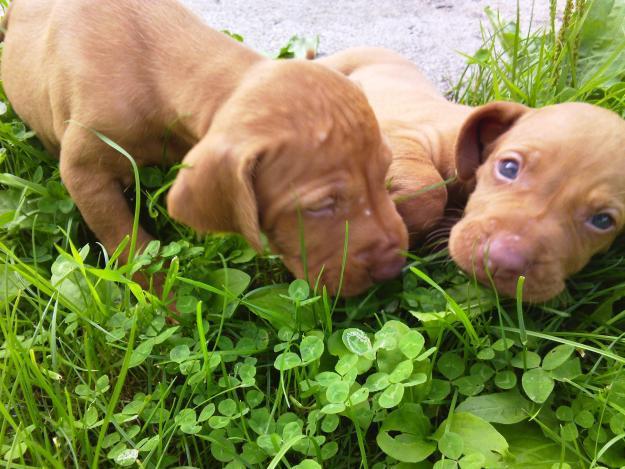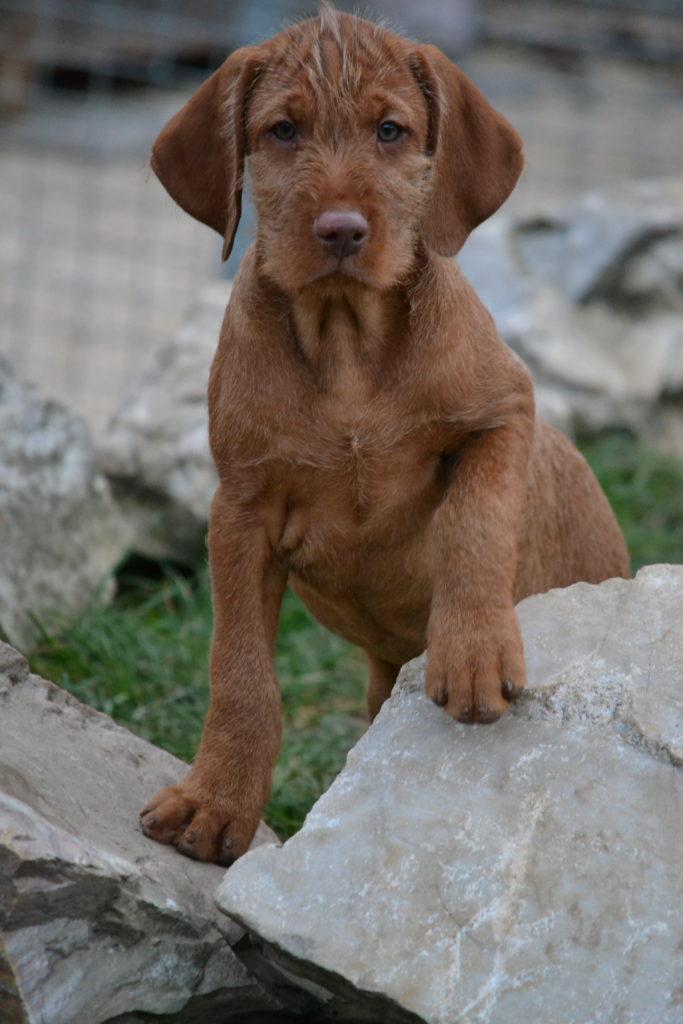The first image is the image on the left, the second image is the image on the right. Given the left and right images, does the statement "The right image features one dog in a sitting pose with body turned left and head turned straight, and the left image features a reclining mother dog with at least four puppies in front of her." hold true? Answer yes or no. No. The first image is the image on the left, the second image is the image on the right. Analyze the images presented: Is the assertion "At least 4 puppies are laying on the ground next to their mama." valid? Answer yes or no. No. 